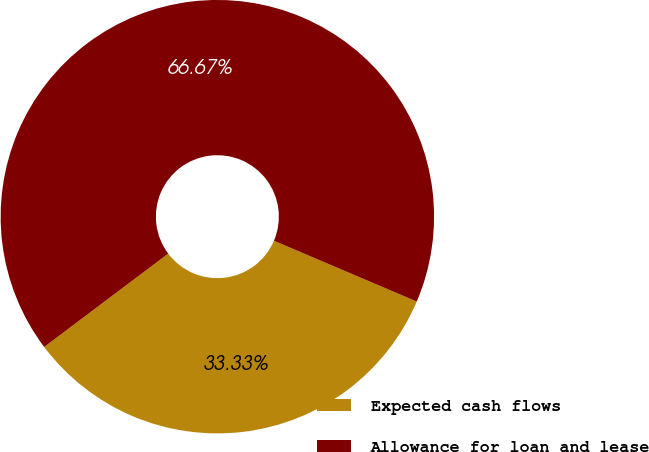Convert chart. <chart><loc_0><loc_0><loc_500><loc_500><pie_chart><fcel>Expected cash flows<fcel>Allowance for loan and lease<nl><fcel>33.33%<fcel>66.67%<nl></chart> 